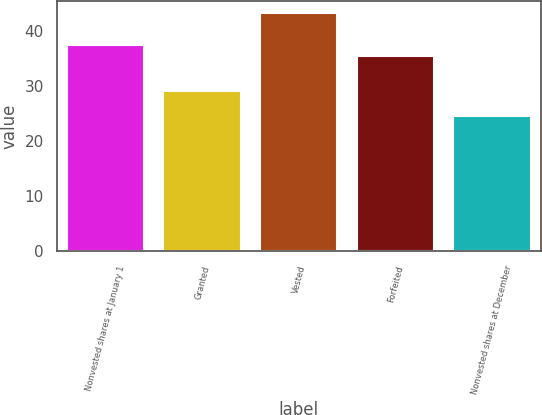<chart> <loc_0><loc_0><loc_500><loc_500><bar_chart><fcel>Nonvested shares at January 1<fcel>Granted<fcel>Vested<fcel>Forfeited<fcel>Nonvested shares at December<nl><fcel>37.46<fcel>29.24<fcel>43.39<fcel>35.58<fcel>24.58<nl></chart> 